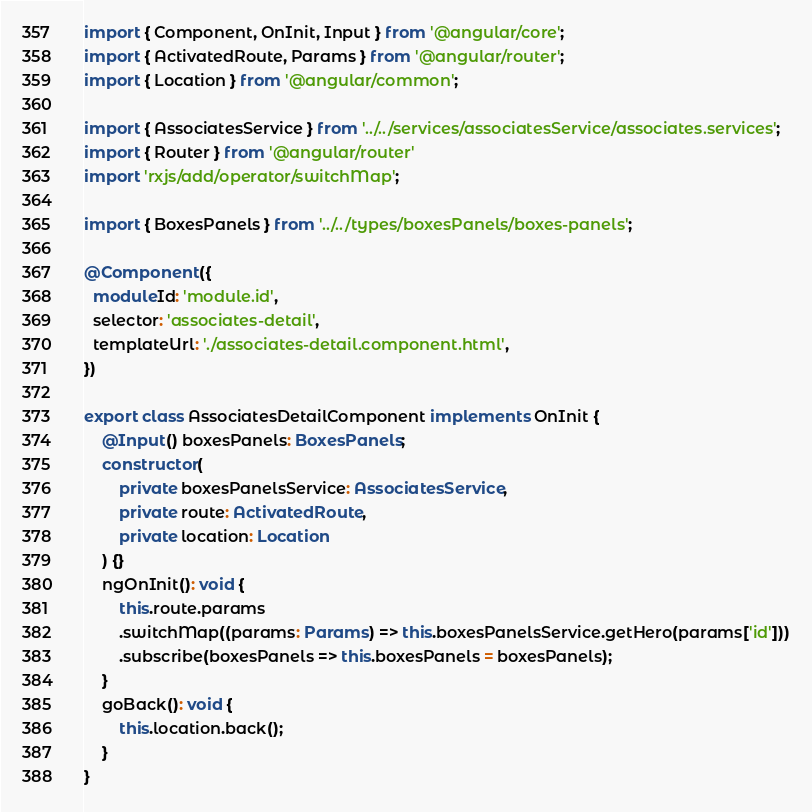Convert code to text. <code><loc_0><loc_0><loc_500><loc_500><_TypeScript_>import { Component, OnInit, Input } from '@angular/core';
import { ActivatedRoute, Params } from '@angular/router';
import { Location } from '@angular/common';

import { AssociatesService } from '../../services/associatesService/associates.services';
import { Router } from '@angular/router'
import 'rxjs/add/operator/switchMap';

import { BoxesPanels } from '../../types/boxesPanels/boxes-panels';

@Component({
  moduleId: 'module.id',
  selector: 'associates-detail',
  templateUrl: './associates-detail.component.html',
})

export class AssociatesDetailComponent implements OnInit {
    @Input() boxesPanels: BoxesPanels;
    constructor(
        private boxesPanelsService: AssociatesService,
        private route: ActivatedRoute,
        private location: Location
    ) {}
    ngOnInit(): void {
        this.route.params
        .switchMap((params: Params) => this.boxesPanelsService.getHero(params['id']))
        .subscribe(boxesPanels => this.boxesPanels = boxesPanels);
    }
    goBack(): void {
        this.location.back();
    }
}</code> 